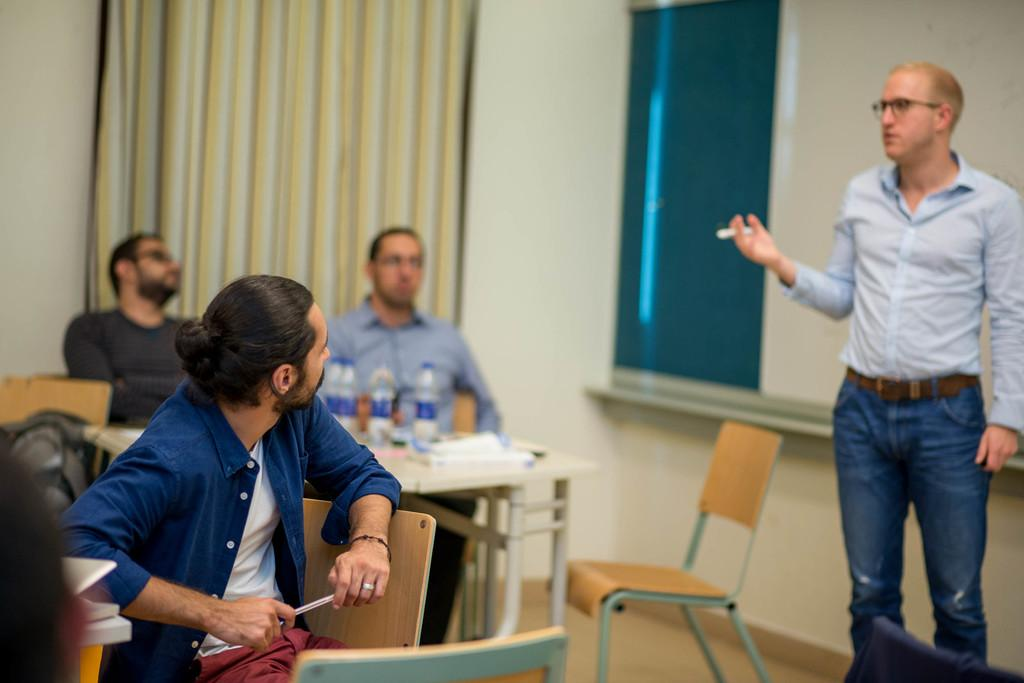How many people are in the image? There are people in the image, but the exact number is not specified. What are some of the people in the image doing? Some people are sitting, and a man is standing. What objects are present in the image that might be used for holding or storing items? There are bottles, chairs, and a table in the image. Can you see a scarf being used as a nest by a bird in the image? No, there is no scarf or bird nest present in the image. Are the people in the image swimming? There is no indication of swimming or any water-related activities in the image. 